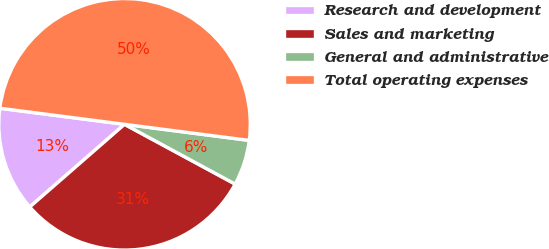<chart> <loc_0><loc_0><loc_500><loc_500><pie_chart><fcel>Research and development<fcel>Sales and marketing<fcel>General and administrative<fcel>Total operating expenses<nl><fcel>13.45%<fcel>30.7%<fcel>5.84%<fcel>50.0%<nl></chart> 